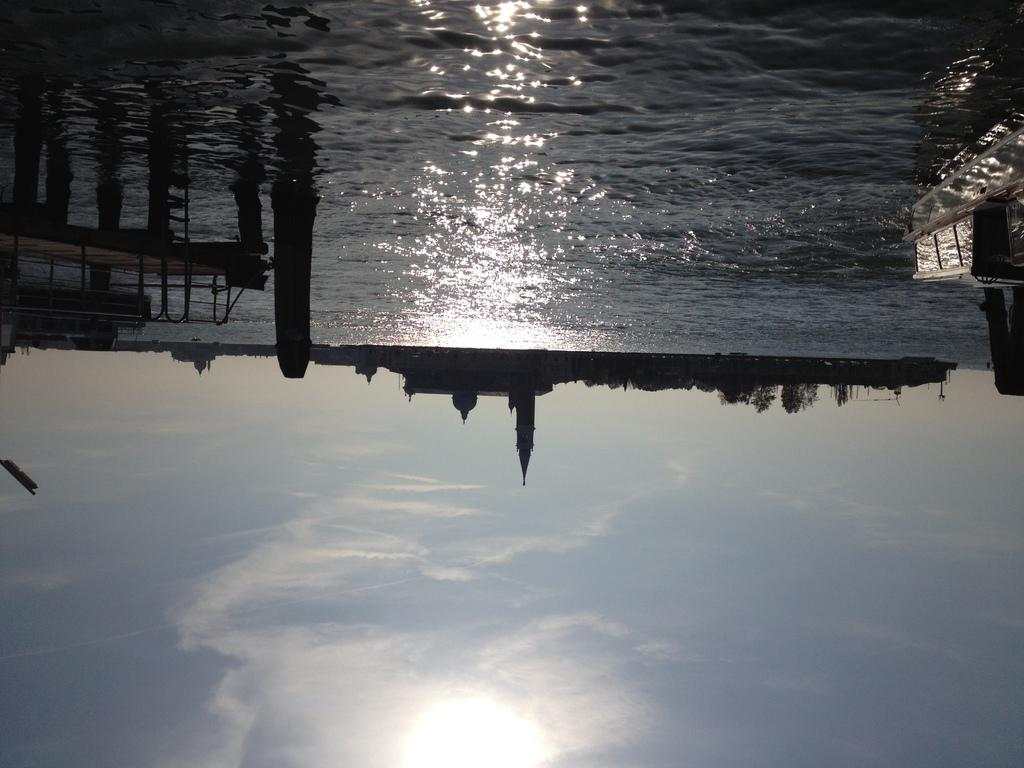What is the main element present in the image? There is water in the image. What type of structure can be seen crossing the water? There is a board bridge in the image. What can be seen in the distance behind the water and bridge? There are buildings in the background of the image. What is visible above the buildings and bridge in the image? The sky is visible in the background of the image. Who is the owner of the paste in the image? There is no paste present in the image, so there is no owner to consider. 